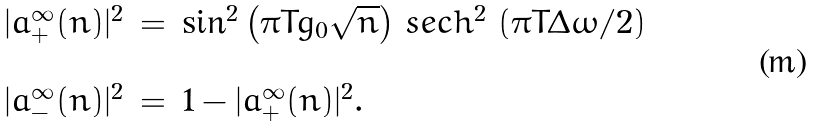Convert formula to latex. <formula><loc_0><loc_0><loc_500><loc_500>\begin{array} { l l l } | a _ { + } ^ { \infty } ( n ) | ^ { 2 } & = & \sin ^ { 2 } \left ( \pi T g _ { 0 } \sqrt { n } \right ) \, s e c h ^ { 2 } \, \left ( \pi T \Delta \omega / 2 \right ) \\ & & \\ | a _ { - } ^ { \infty } ( n ) | ^ { 2 } & = & 1 - | a _ { + } ^ { \infty } ( n ) | ^ { 2 } . \end{array}</formula> 